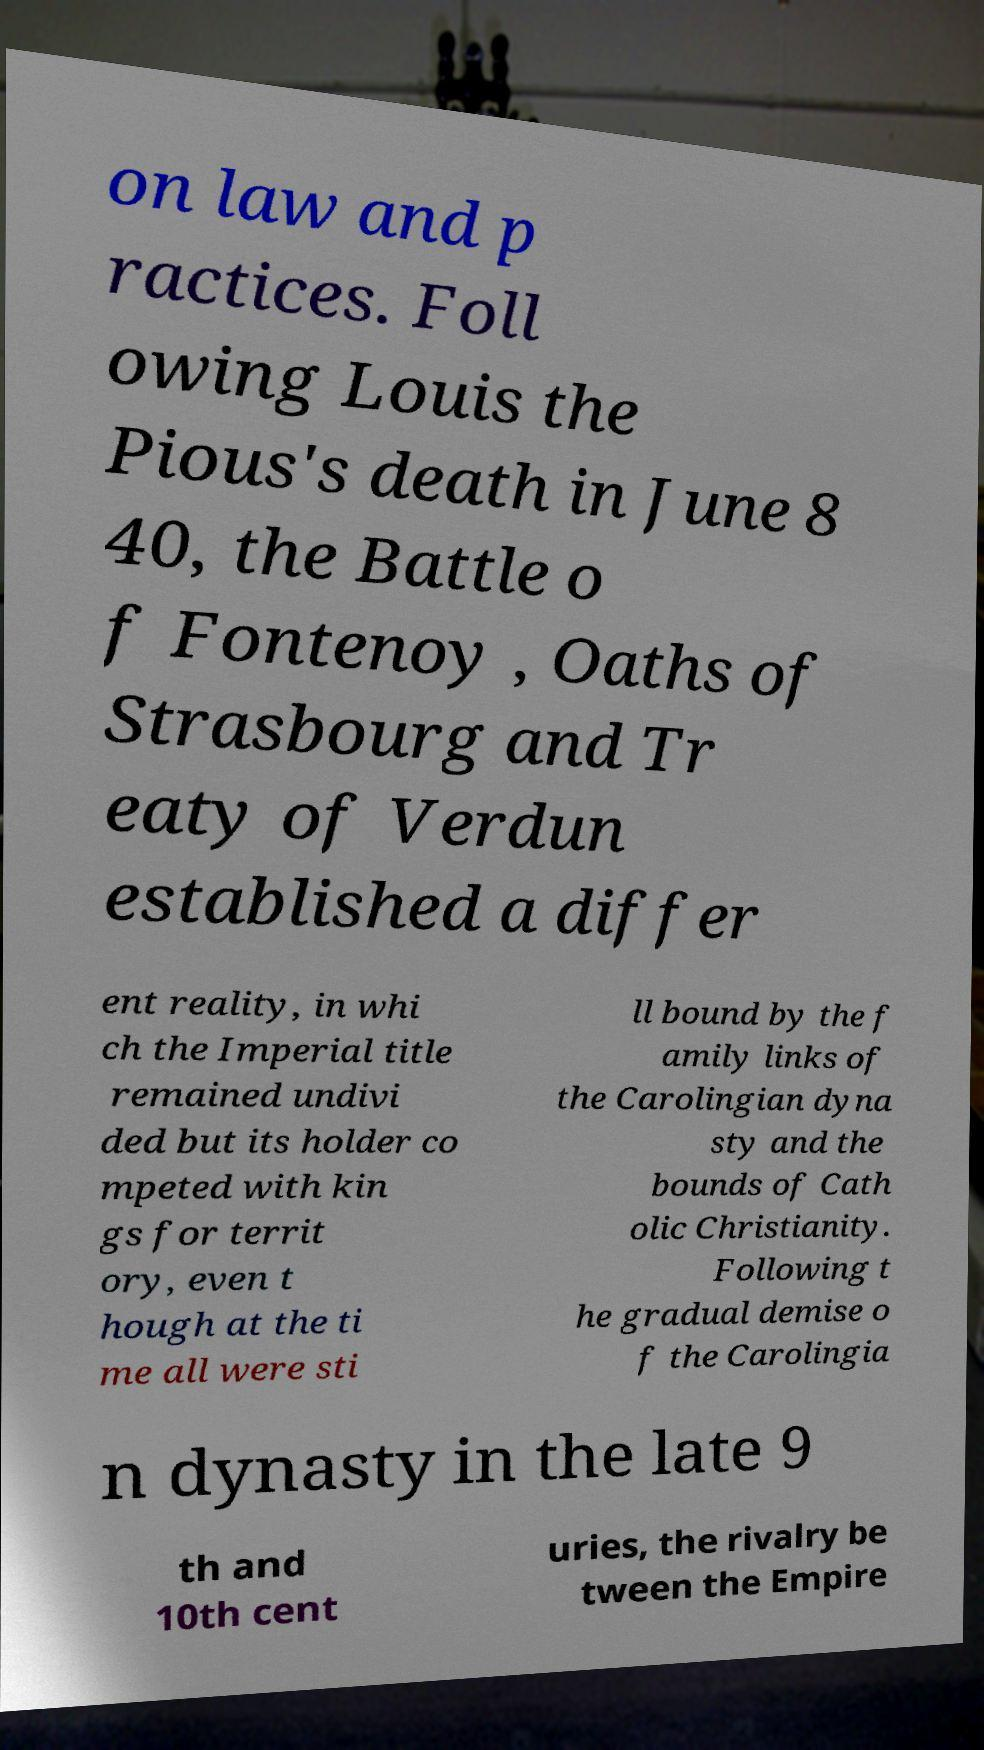Please read and relay the text visible in this image. What does it say? on law and p ractices. Foll owing Louis the Pious's death in June 8 40, the Battle o f Fontenoy , Oaths of Strasbourg and Tr eaty of Verdun established a differ ent reality, in whi ch the Imperial title remained undivi ded but its holder co mpeted with kin gs for territ ory, even t hough at the ti me all were sti ll bound by the f amily links of the Carolingian dyna sty and the bounds of Cath olic Christianity. Following t he gradual demise o f the Carolingia n dynasty in the late 9 th and 10th cent uries, the rivalry be tween the Empire 